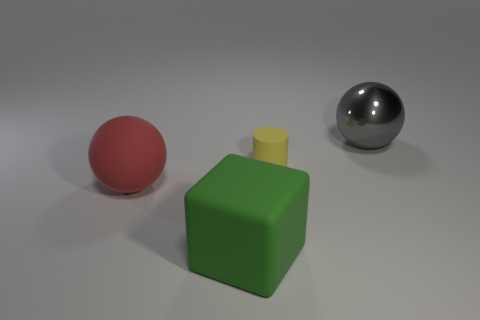Is there anything else that has the same size as the yellow rubber object?
Your response must be concise. No. Are there more tiny brown metal spheres than small rubber things?
Ensure brevity in your answer.  No. Do the red rubber object that is in front of the yellow object and the sphere on the right side of the tiny yellow cylinder have the same size?
Provide a short and direct response. Yes. What color is the big matte thing that is behind the large matte thing in front of the large sphere that is in front of the large gray object?
Provide a short and direct response. Red. Are there any tiny green rubber things that have the same shape as the red thing?
Give a very brief answer. No. Are there more big metallic objects behind the gray shiny thing than cyan objects?
Your response must be concise. No. What number of matte things are either gray things or tiny red blocks?
Your answer should be compact. 0. There is a thing that is both behind the red thing and on the left side of the shiny thing; what is its size?
Your answer should be very brief. Small. There is a ball left of the gray sphere; are there any matte things to the left of it?
Give a very brief answer. No. What number of red things are on the left side of the big red object?
Make the answer very short. 0. 